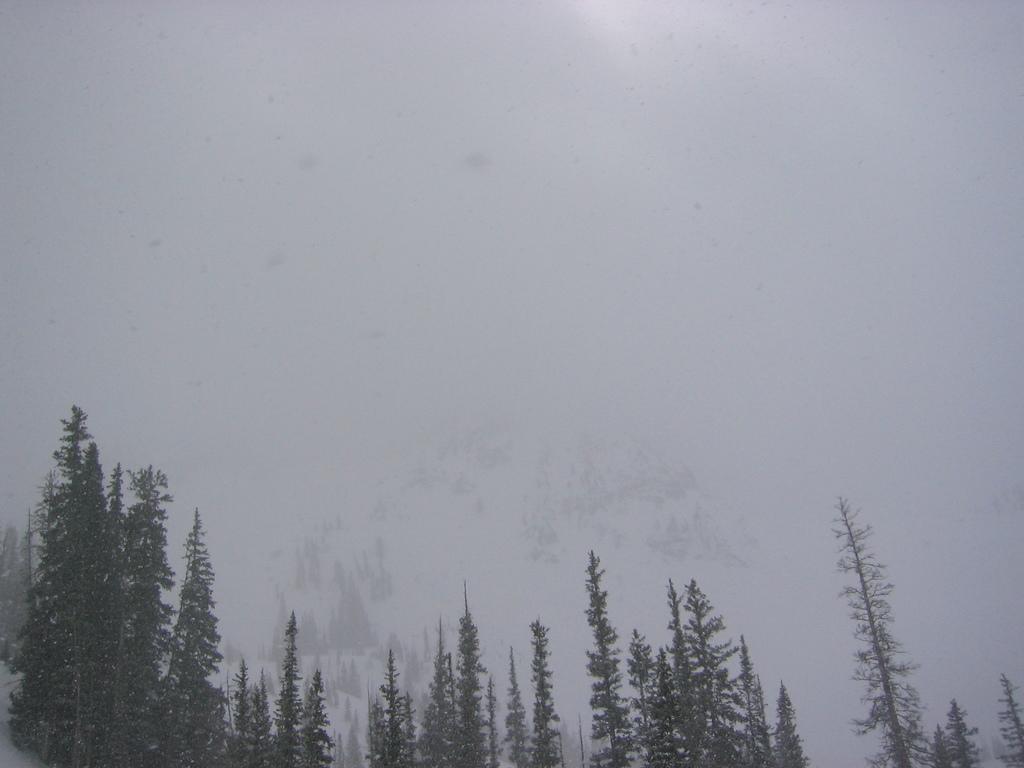Could you give a brief overview of what you see in this image? In this picture we can see few trees and snow. 